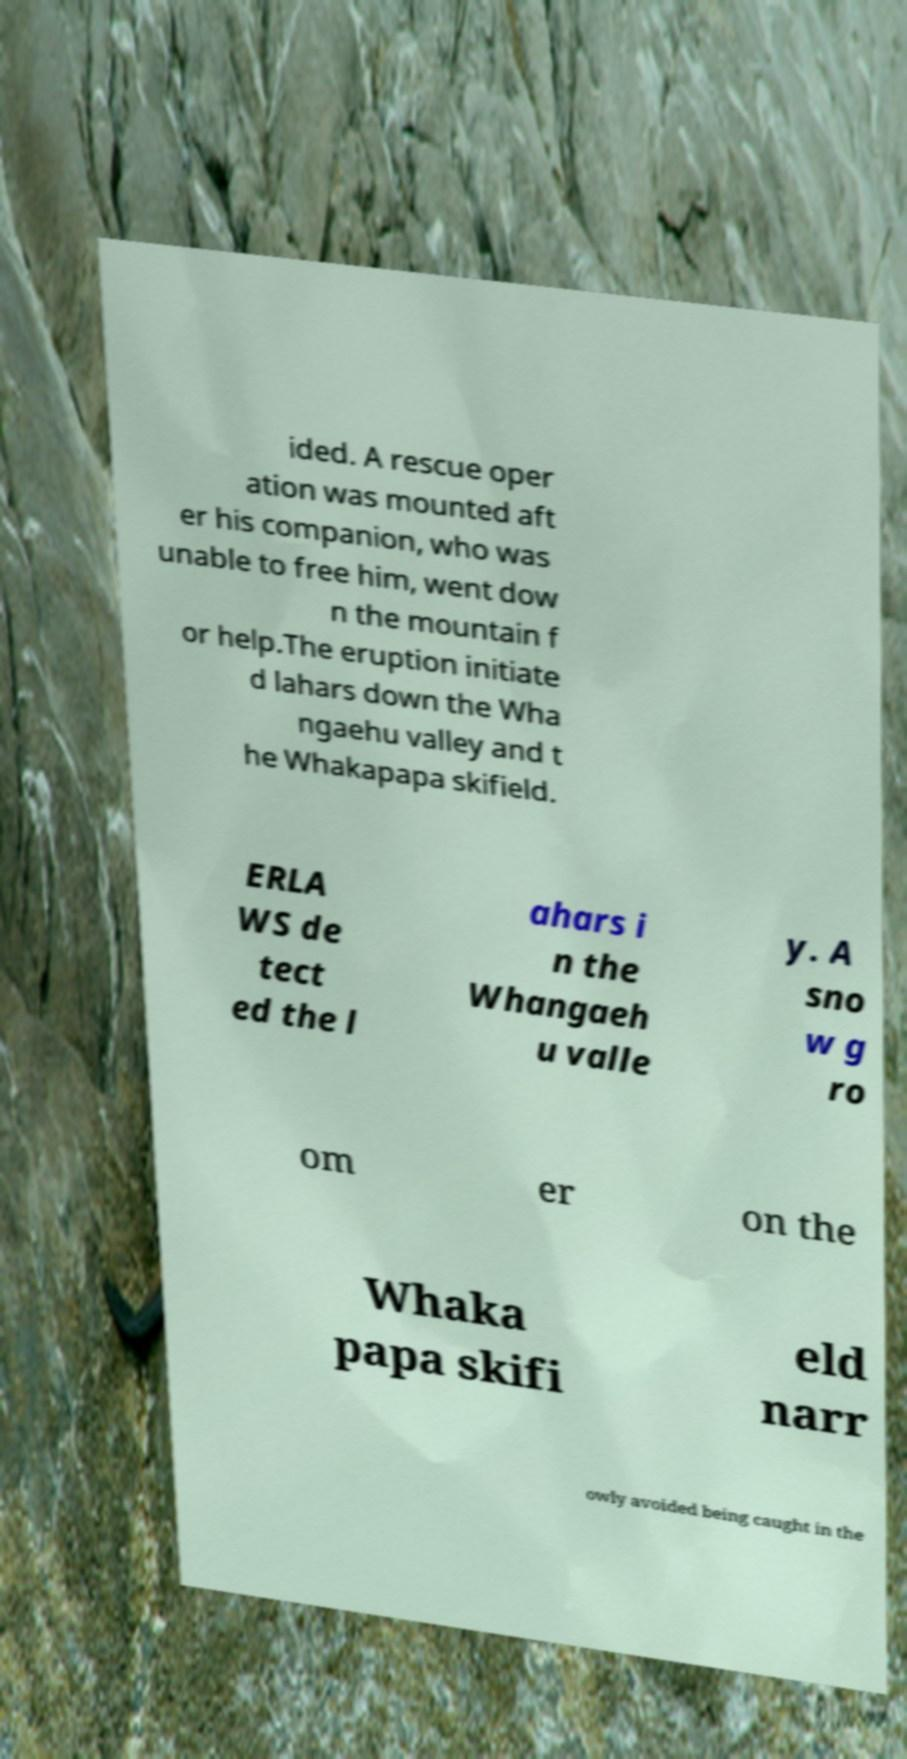What messages or text are displayed in this image? I need them in a readable, typed format. ided. A rescue oper ation was mounted aft er his companion, who was unable to free him, went dow n the mountain f or help.The eruption initiate d lahars down the Wha ngaehu valley and t he Whakapapa skifield. ERLA WS de tect ed the l ahars i n the Whangaeh u valle y. A sno w g ro om er on the Whaka papa skifi eld narr owly avoided being caught in the 